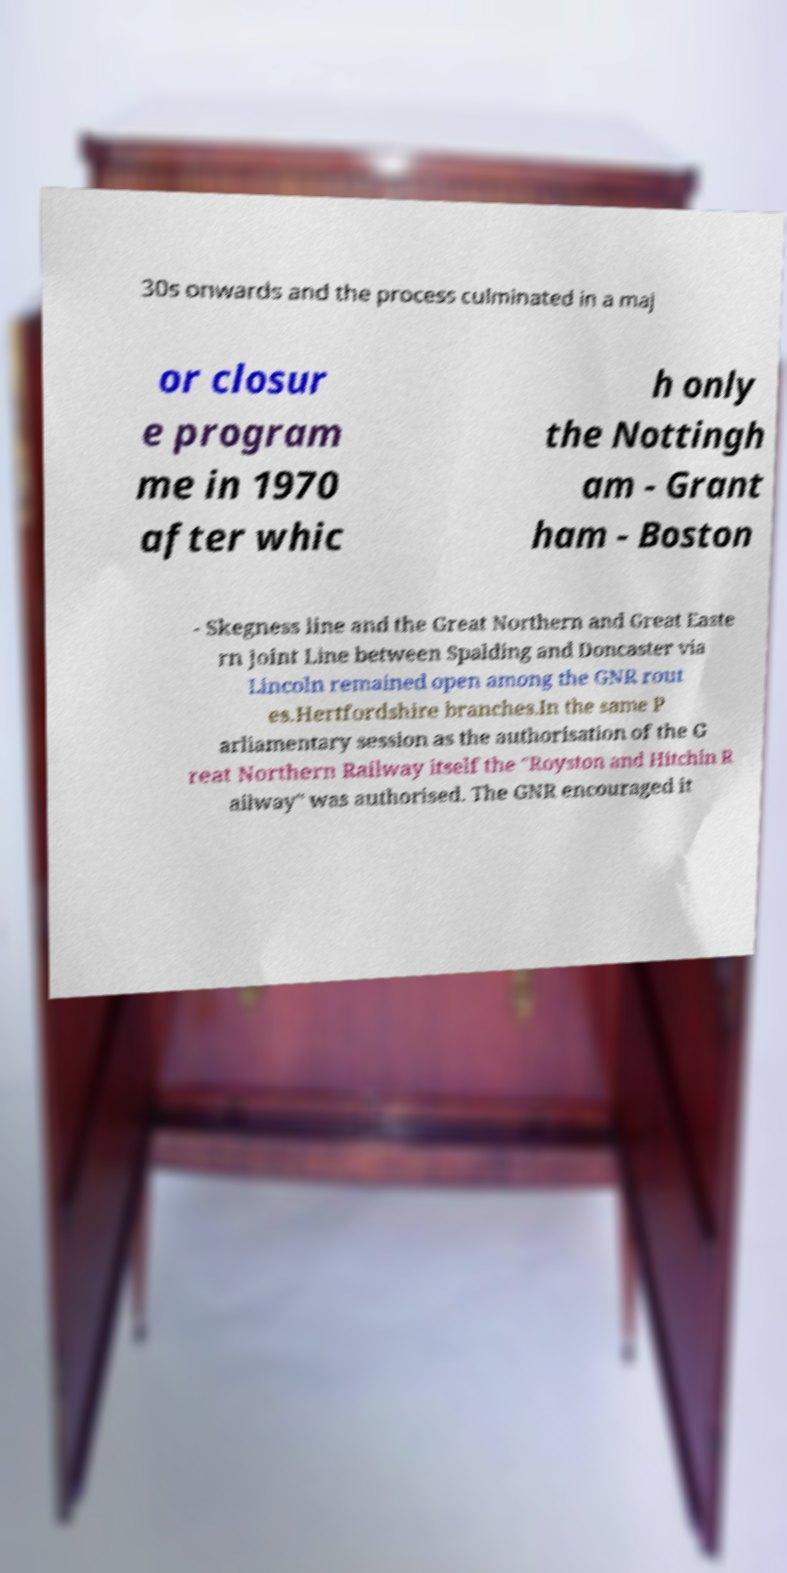There's text embedded in this image that I need extracted. Can you transcribe it verbatim? 30s onwards and the process culminated in a maj or closur e program me in 1970 after whic h only the Nottingh am - Grant ham - Boston - Skegness line and the Great Northern and Great Easte rn Joint Line between Spalding and Doncaster via Lincoln remained open among the GNR rout es.Hertfordshire branches.In the same P arliamentary session as the authorisation of the G reat Northern Railway itself the "Royston and Hitchin R ailway" was authorised. The GNR encouraged it 